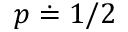<formula> <loc_0><loc_0><loc_500><loc_500>p \doteq 1 / 2</formula> 